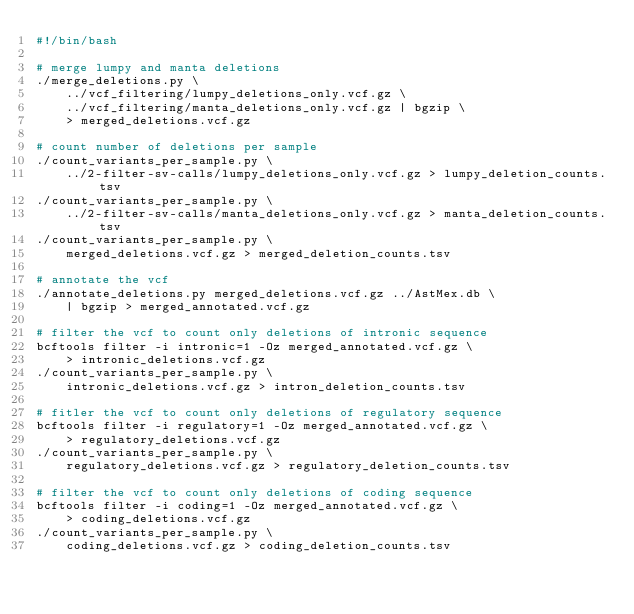<code> <loc_0><loc_0><loc_500><loc_500><_Bash_>#!/bin/bash

# merge lumpy and manta deletions
./merge_deletions.py \
    ../vcf_filtering/lumpy_deletions_only.vcf.gz \
    ../vcf_filtering/manta_deletions_only.vcf.gz | bgzip \
    > merged_deletions.vcf.gz

# count number of deletions per sample
./count_variants_per_sample.py \
    ../2-filter-sv-calls/lumpy_deletions_only.vcf.gz > lumpy_deletion_counts.tsv
./count_variants_per_sample.py \
    ../2-filter-sv-calls/manta_deletions_only.vcf.gz > manta_deletion_counts.tsv
./count_variants_per_sample.py \
    merged_deletions.vcf.gz > merged_deletion_counts.tsv

# annotate the vcf
./annotate_deletions.py merged_deletions.vcf.gz ../AstMex.db \
    | bgzip > merged_annotated.vcf.gz

# filter the vcf to count only deletions of intronic sequence
bcftools filter -i intronic=1 -Oz merged_annotated.vcf.gz \
    > intronic_deletions.vcf.gz
./count_variants_per_sample.py \
    intronic_deletions.vcf.gz > intron_deletion_counts.tsv

# fitler the vcf to count only deletions of regulatory sequence
bcftools filter -i regulatory=1 -Oz merged_annotated.vcf.gz \
    > regulatory_deletions.vcf.gz
./count_variants_per_sample.py \
    regulatory_deletions.vcf.gz > regulatory_deletion_counts.tsv

# filter the vcf to count only deletions of coding sequence
bcftools filter -i coding=1 -Oz merged_annotated.vcf.gz \
    > coding_deletions.vcf.gz
./count_variants_per_sample.py \
    coding_deletions.vcf.gz > coding_deletion_counts.tsv
</code> 